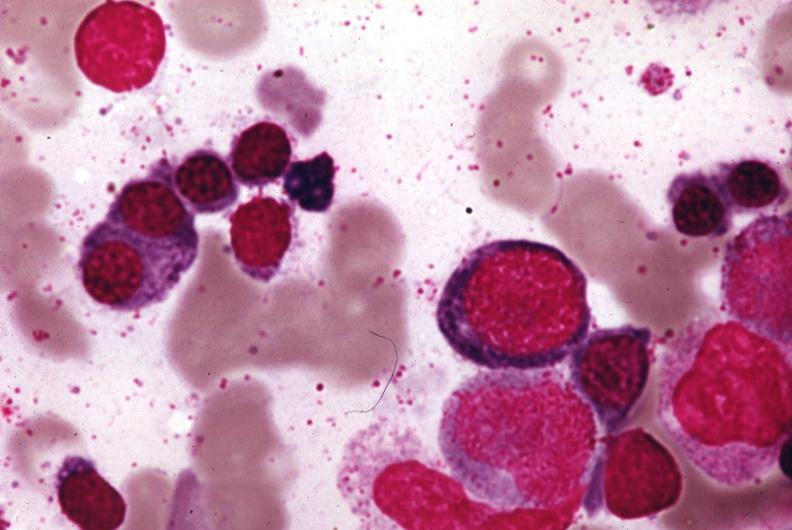what is present?
Answer the question using a single word or phrase. Megaloblasts pernicious anemia 